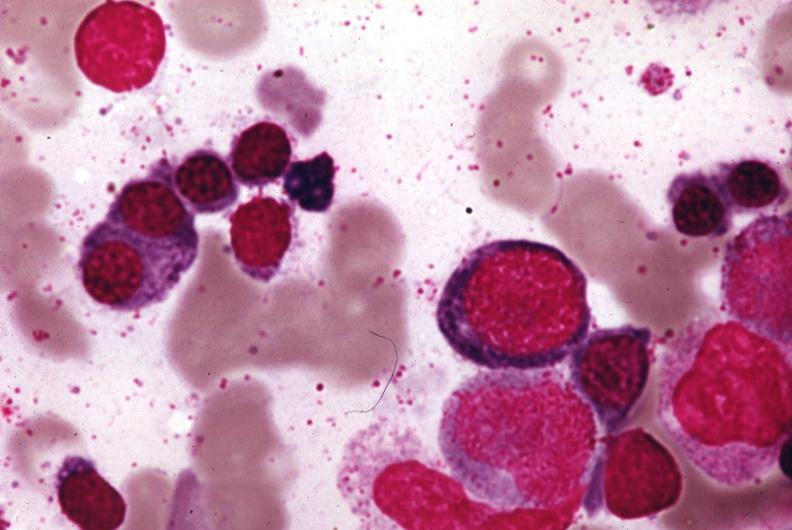what is present?
Answer the question using a single word or phrase. Megaloblasts pernicious anemia 